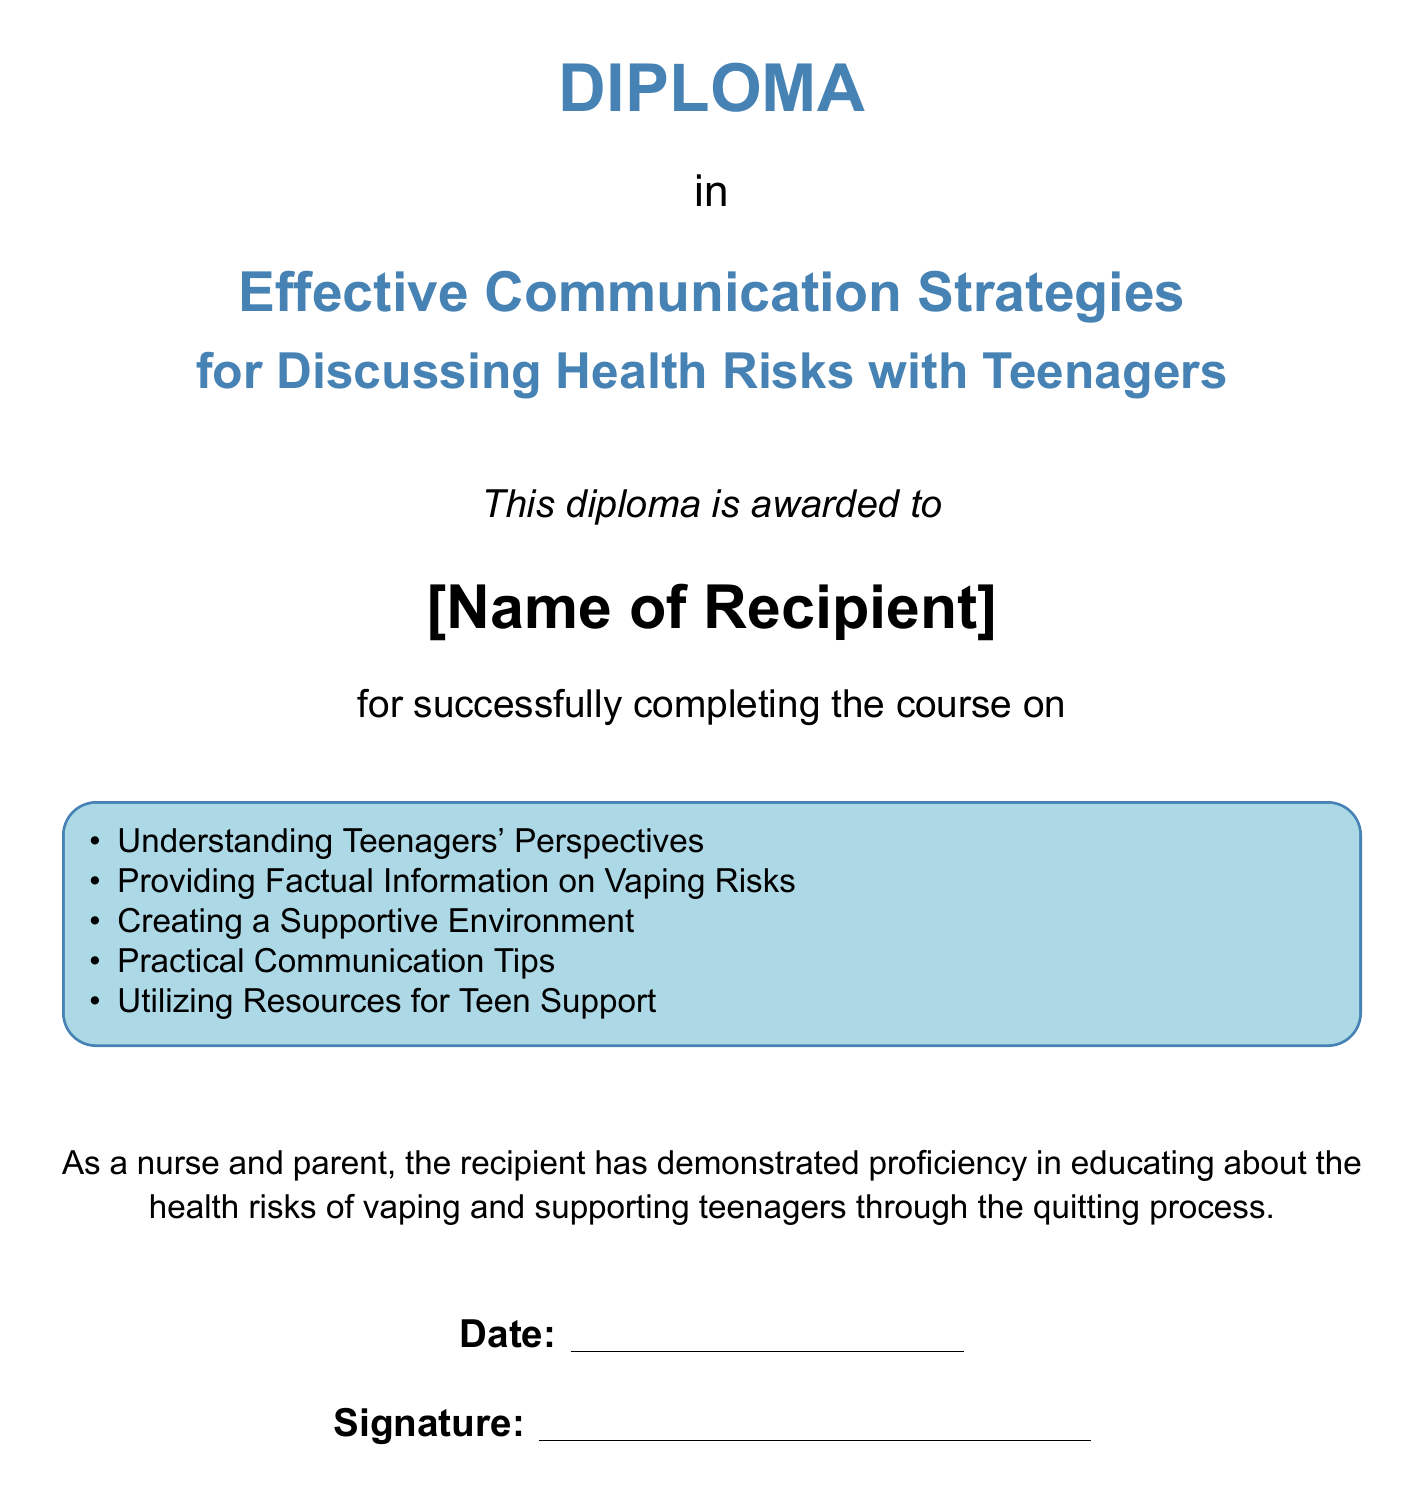What is the title of the diploma? The title of the diploma is clearly stated in the document, which is "Effective Communication Strategies for Discussing Health Risks with Teenagers."
Answer: Effective Communication Strategies for Discussing Health Risks with Teenagers Who is the diploma awarded to? The diploma explicitly mentions that it is awarded to "[Name of Recipient]."
Answer: [Name of Recipient] What does the diploma recognize the recipient for? The recipient is recognized for completing a course related to educating about health risks and supporting teenagers.
Answer: successfully completing the course What color is the box that contains the list of topics? The box containing the list of topics is colored light blue.
Answer: light blue How many topics are listed in the diploma? The number of topics listed in the tcolorbox is five.
Answer: 5 What role does the diploma state the recipient has demonstrated proficiency in? The role mentioned in the diploma is that of a nurse and parent.
Answer: nurse and parent What is the significance of the date and signature sections at the bottom? The date and signature sections are typically used for validation of the diploma by providing the date of issuance and the signature of the authority.
Answer: validation What is the main focus of the diploma? The main focus of the diploma is effectively communicating health risks to teenagers, particularly regarding vaping.
Answer: effectively communicating health risks to teenagers 